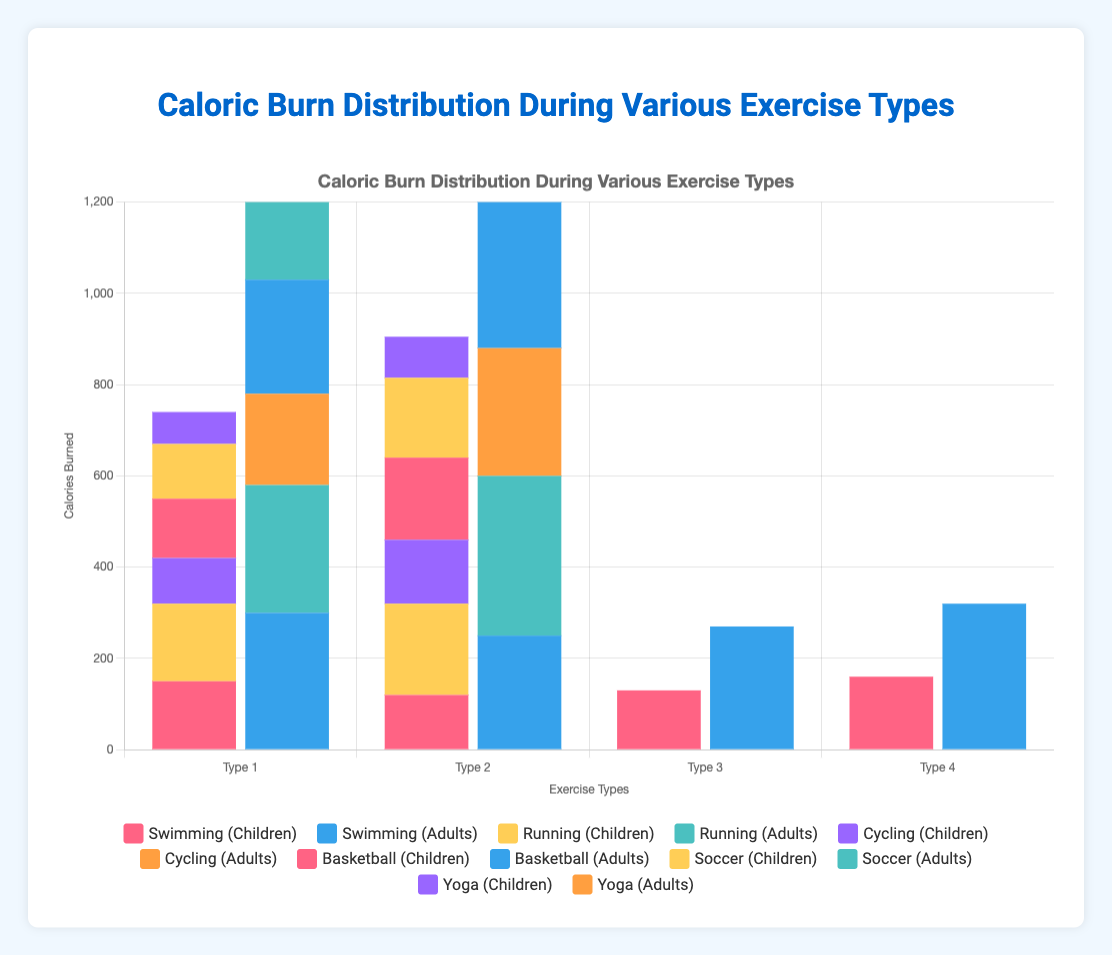How many calories do children burn in total for all swim strokes combined? To find the total calories burned by children for all swim strokes, sum the calories burned for Freestyle (150), Breaststroke (120), Backstroke (130), and Butterfly (160). The calculation is 150 + 120 + 130 + 160 = 560.
Answer: 560 Which age group burns more calories while running competitively, and by how much? Compare the calories burned by children and adults during competitive running. Adults burn 350 calories while sprinting, whereas children do not have a specific "competitive" category for running. The comparison based on available data (children's sprinting) shows that adults burn more (350 - 200 = 150).
Answer: Adults, 150 For which exercise type is the difference in caloric burn between children and adults the greatest? Calculate the difference in calories burned for each exercise type between children and adults. The differences are: 
Swimming Butterfly (320 - 160 = 160), Running Sprinting (350 - 200 = 150), Cycling Mountain (280 - 140 = 140), Basketball Competitive (330 - 180 = 150), Soccer Competitive (320 - 175 = 145), Yoga Vinyasa (180 - 90 = 90). The greatest difference is in Swimming Butterfly.
Answer: Swimming Butterfly Compare the total calories burned by adults during yoga and casual basketball. Sum the calories burned by adults during Hatha (150) and Vinyasa (180) yoga, and Casual basketball (250). The calculation is 150 + 180 = 330 for yoga, and Casual basketball is 250. Comparison shows 330 for yoga is greater than 250 for casual basketball.
Answer: Yoga Which exercise type shows the smallest difference in caloric burn between children and adults, and what is the value? Calculate the difference in calories burned by children and adults for each exercise type: Swimming Freestyle (300-150=150), Running Jogging (280-170=110), Cycling Leisure (200-100=100), Basketball Casual (250-130=120), Soccer Casual (240-120=120), Yoga Hatha (150-70=80). The smallest difference is in Yoga Hatha.
Answer: Yoga Hatha, 80 Across all exercise types, which exercise burns the most calories for children and what is the value? Identify the highest caloric burn value in the Children's categories followed by summing or checking individually. Notable individual values include: Butterfly swimming (160), Sprinting (200), Mountain biking (140), Competitive Basketball (180), Competitive Soccer (175), Vinyasa Yoga (90). The highest is Sprinting with 200 calories.
Answer: Running Sprinting, 200 What is the total caloric burn for adults across all types of swimming strokes? Sum the calories burned by adults for Freestyle (300), Breaststroke (250), Backstroke (270), and Butterfly (320) swimming strokes. The calculation is 300 + 250 + 270 + 320 = 1140.
Answer: 1140 Is the caloric burn during competitive soccer higher or lower than during competitive basketball for adults, and by how much? Compare caloric burn values for adults during competitive soccer (320) and competitive basketball (330). Subtract to find the difference, which is 330 - 320 = 10. The competitive basketball burns 10 calories more.
Answer: Higher, 10 